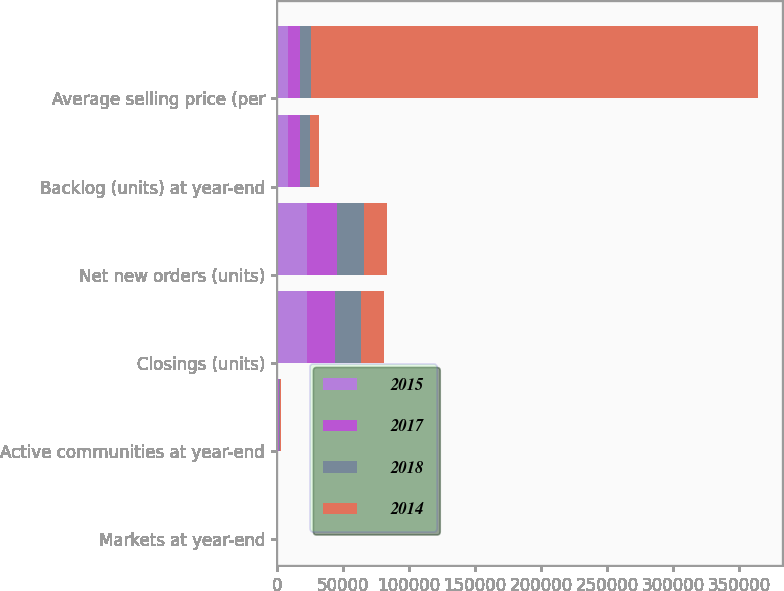<chart> <loc_0><loc_0><loc_500><loc_500><stacked_bar_chart><ecel><fcel>Markets at year-end<fcel>Active communities at year-end<fcel>Closings (units)<fcel>Net new orders (units)<fcel>Backlog (units) at year-end<fcel>Average selling price (per<nl><fcel>2015<fcel>44<fcel>815<fcel>23107<fcel>22833<fcel>8722<fcel>8722<nl><fcel>2017<fcel>47<fcel>790<fcel>21052<fcel>22626<fcel>8996<fcel>8722<nl><fcel>2018<fcel>49<fcel>726<fcel>19951<fcel>20326<fcel>7422<fcel>8722<nl><fcel>2014<fcel>50<fcel>620<fcel>17127<fcel>18008<fcel>6731<fcel>338000<nl></chart> 